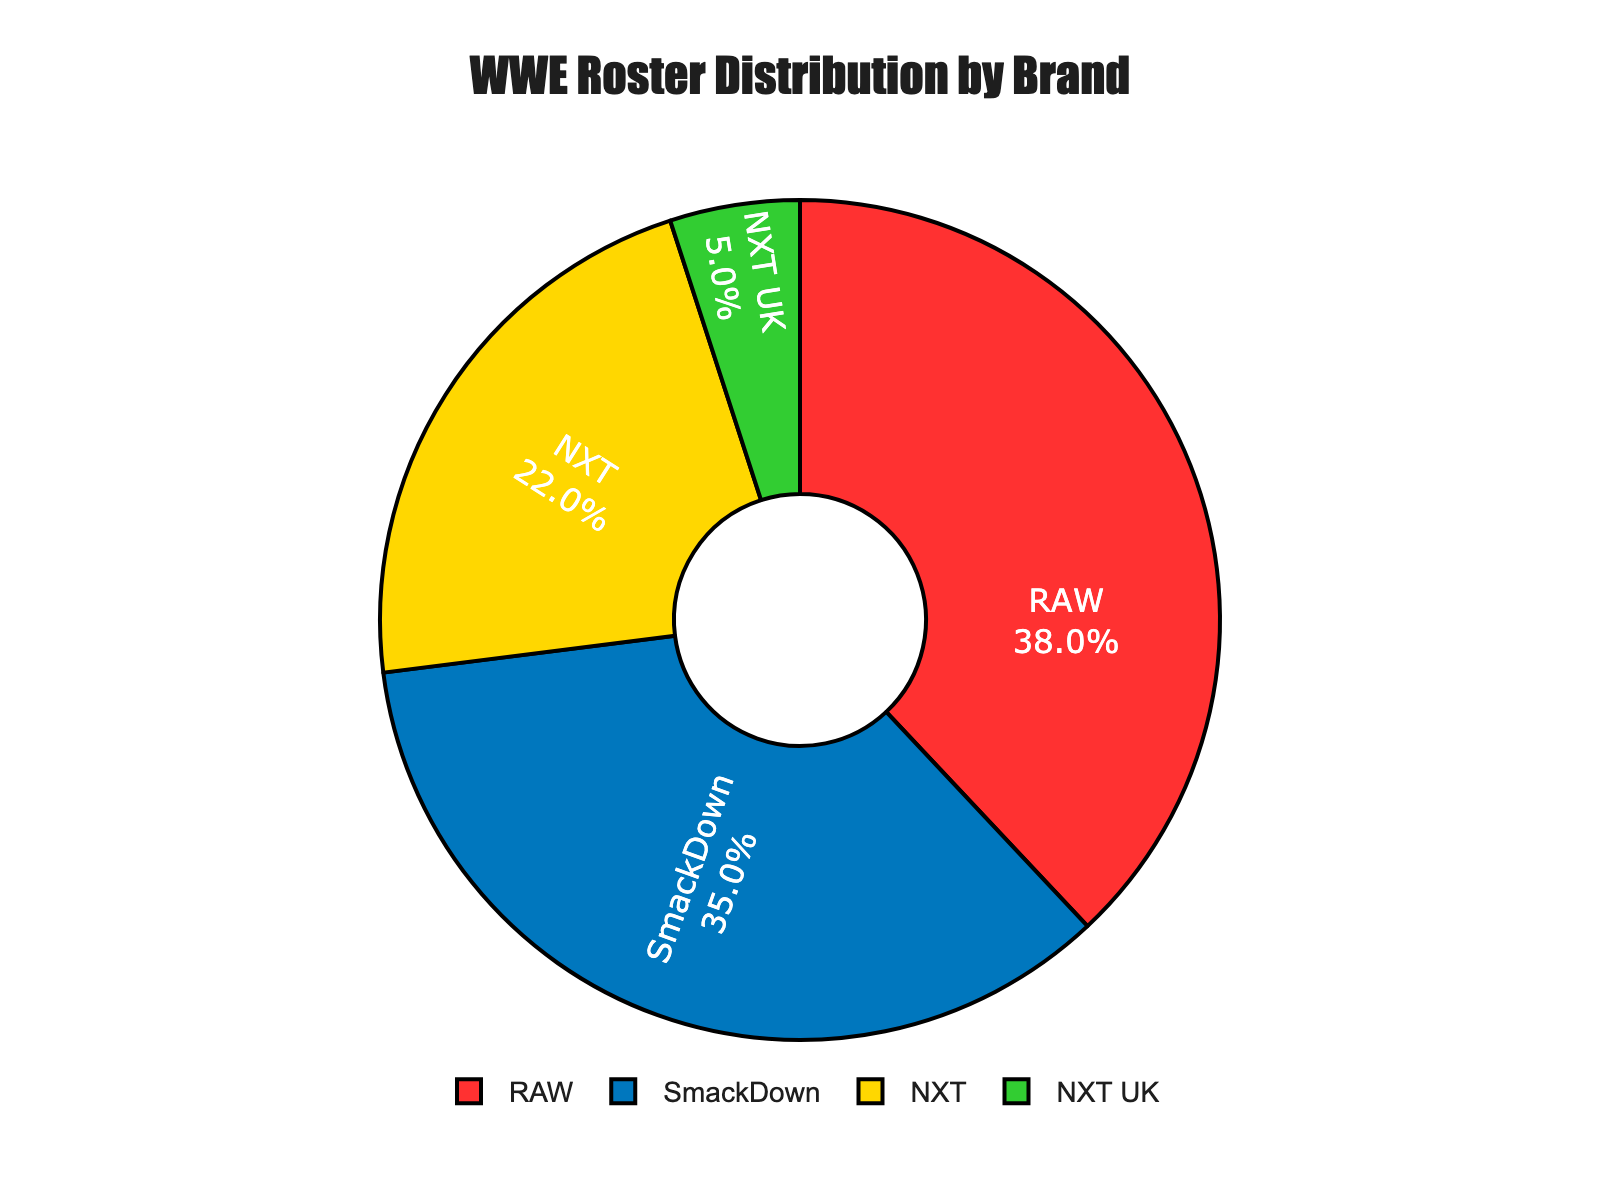What's the largest brand in the roster by percentage? By looking at the figure, identify the brand with the largest percentage visually. RAW is the largest segment in the pie chart.
Answer: RAW What's the combined percentage of the RAW and SmackDown rosters? Add the percentages of RAW and SmackDown brands from the figure (38% + 35% = 73%).
Answer: 73% Which brand has the smallest representation in the WWE roster? Look for the smallest segment in the pie chart. NXT UK is the smallest with 5%.
Answer: NXT UK What percentage of the roster does the NXT brand represent? Find the segment labeled NXT in the pie chart and note its percentage. The NXT brand represents 22%.
Answer: 22% How much larger is the RAW roster percentage compared to NXT? Subtract the NXT percentage from the RAW percentage (38% - 22% = 16%).
Answer: 16% What is the difference in representation between NXT and SmackDown? Subtract the NXT percentage from the SmackDown percentage (35% - 22% = 13%).
Answer: 13% If the total WWE roster consists of 200 wrestlers, how many wrestlers belong to NXT UK? Use the NXT UK percentage (5%) and multiply by the total roster size (200 * 0.05 = 10 wrestlers).
Answer: 10 Among RAW, SmackDown, and NXT, which two brands have the closest representation percentage? Compare the differences between the percentages: 
RAW vs. SmackDown (38% - 35% = 3%), 
SmackDown vs. NXT (35% - 22% = 13%), 
RAW vs. NXT (38% - 22% = 16%). 
The smallest difference is between RAW and SmackDown (3%).
Answer: RAW and SmackDown What is the sum percentage of all NXT-related brands (NXT and NXT UK) in the WWE roster? Add the percentages of NXT and NXT UK (22% + 5% = 27%).
Answer: 27% How evenly distributed are the percentages between RAW and SmackDown brands? Compare the RAW and SmackDown percentages visually. RAW has 38% and SmackDown has 35%, showing a nearly even distribution, with a small difference of 3%.
Answer: Nearly even 